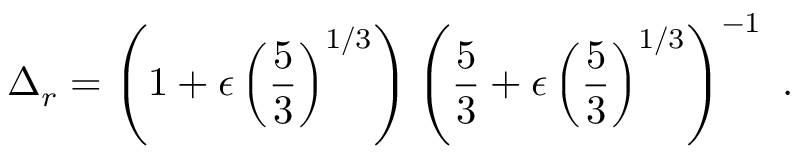Convert formula to latex. <formula><loc_0><loc_0><loc_500><loc_500>\Delta _ { r } = \left ( 1 + \epsilon \left ( \frac { 5 } { 3 } \right ) ^ { 1 / 3 } \right ) \left ( \frac { 5 } { 3 } + \epsilon \left ( \frac { 5 } { 3 } \right ) ^ { 1 / 3 } \right ) ^ { - 1 } \ .</formula> 